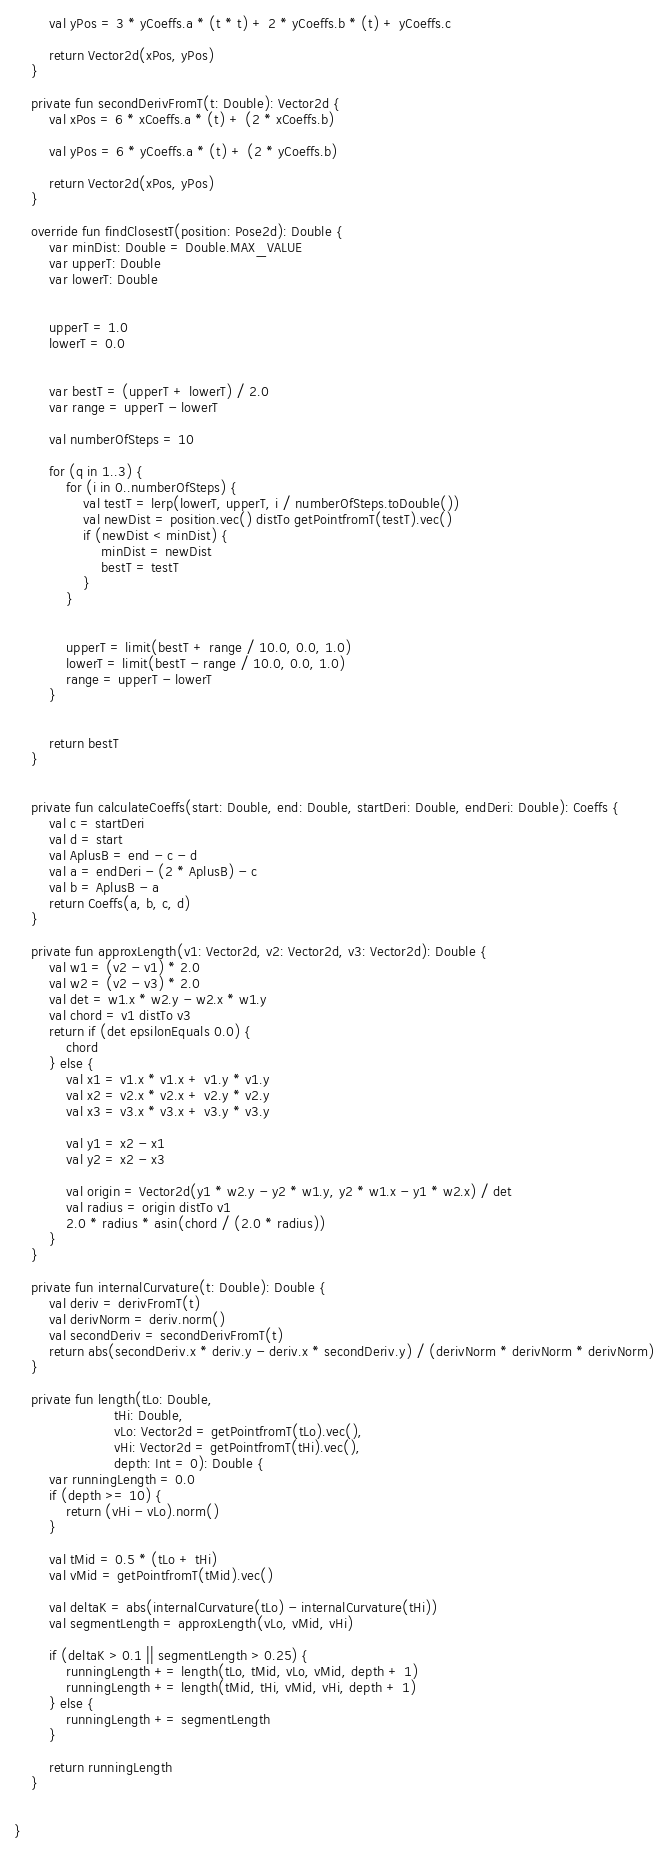Convert code to text. <code><loc_0><loc_0><loc_500><loc_500><_Kotlin_>        val yPos = 3 * yCoeffs.a * (t * t) + 2 * yCoeffs.b * (t) + yCoeffs.c

        return Vector2d(xPos, yPos)
    }

    private fun secondDerivFromT(t: Double): Vector2d {
        val xPos = 6 * xCoeffs.a * (t) + (2 * xCoeffs.b)

        val yPos = 6 * yCoeffs.a * (t) + (2 * yCoeffs.b)

        return Vector2d(xPos, yPos)
    }

    override fun findClosestT(position: Pose2d): Double {
        var minDist: Double = Double.MAX_VALUE
        var upperT: Double
        var lowerT: Double


        upperT = 1.0
        lowerT = 0.0


        var bestT = (upperT + lowerT) / 2.0
        var range = upperT - lowerT

        val numberOfSteps = 10

        for (q in 1..3) {
            for (i in 0..numberOfSteps) {
                val testT = lerp(lowerT, upperT, i / numberOfSteps.toDouble())
                val newDist = position.vec() distTo getPointfromT(testT).vec()
                if (newDist < minDist) {
                    minDist = newDist
                    bestT = testT
                }
            }


            upperT = limit(bestT + range / 10.0, 0.0, 1.0)
            lowerT = limit(bestT - range / 10.0, 0.0, 1.0)
            range = upperT - lowerT
        }


        return bestT
    }


    private fun calculateCoeffs(start: Double, end: Double, startDeri: Double, endDeri: Double): Coeffs {
        val c = startDeri
        val d = start
        val AplusB = end - c - d
        val a = endDeri - (2 * AplusB) - c
        val b = AplusB - a
        return Coeffs(a, b, c, d)
    }

    private fun approxLength(v1: Vector2d, v2: Vector2d, v3: Vector2d): Double {
        val w1 = (v2 - v1) * 2.0
        val w2 = (v2 - v3) * 2.0
        val det = w1.x * w2.y - w2.x * w1.y
        val chord = v1 distTo v3
        return if (det epsilonEquals 0.0) {
            chord
        } else {
            val x1 = v1.x * v1.x + v1.y * v1.y
            val x2 = v2.x * v2.x + v2.y * v2.y
            val x3 = v3.x * v3.x + v3.y * v3.y

            val y1 = x2 - x1
            val y2 = x2 - x3

            val origin = Vector2d(y1 * w2.y - y2 * w1.y, y2 * w1.x - y1 * w2.x) / det
            val radius = origin distTo v1
            2.0 * radius * asin(chord / (2.0 * radius))
        }
    }

    private fun internalCurvature(t: Double): Double {
        val deriv = derivFromT(t)
        val derivNorm = deriv.norm()
        val secondDeriv = secondDerivFromT(t)
        return abs(secondDeriv.x * deriv.y - deriv.x * secondDeriv.y) / (derivNorm * derivNorm * derivNorm)
    }

    private fun length(tLo: Double,
                       tHi: Double,
                       vLo: Vector2d = getPointfromT(tLo).vec(),
                       vHi: Vector2d = getPointfromT(tHi).vec(),
                       depth: Int = 0): Double {
        var runningLength = 0.0
        if (depth >= 10) {
            return (vHi - vLo).norm()
        }

        val tMid = 0.5 * (tLo + tHi)
        val vMid = getPointfromT(tMid).vec()

        val deltaK = abs(internalCurvature(tLo) - internalCurvature(tHi))
        val segmentLength = approxLength(vLo, vMid, vHi)

        if (deltaK > 0.1 || segmentLength > 0.25) {
            runningLength += length(tLo, tMid, vLo, vMid, depth + 1)
            runningLength += length(tMid, tHi, vMid, vHi, depth + 1)
        } else {
            runningLength += segmentLength
        }

        return runningLength
    }


}

</code> 